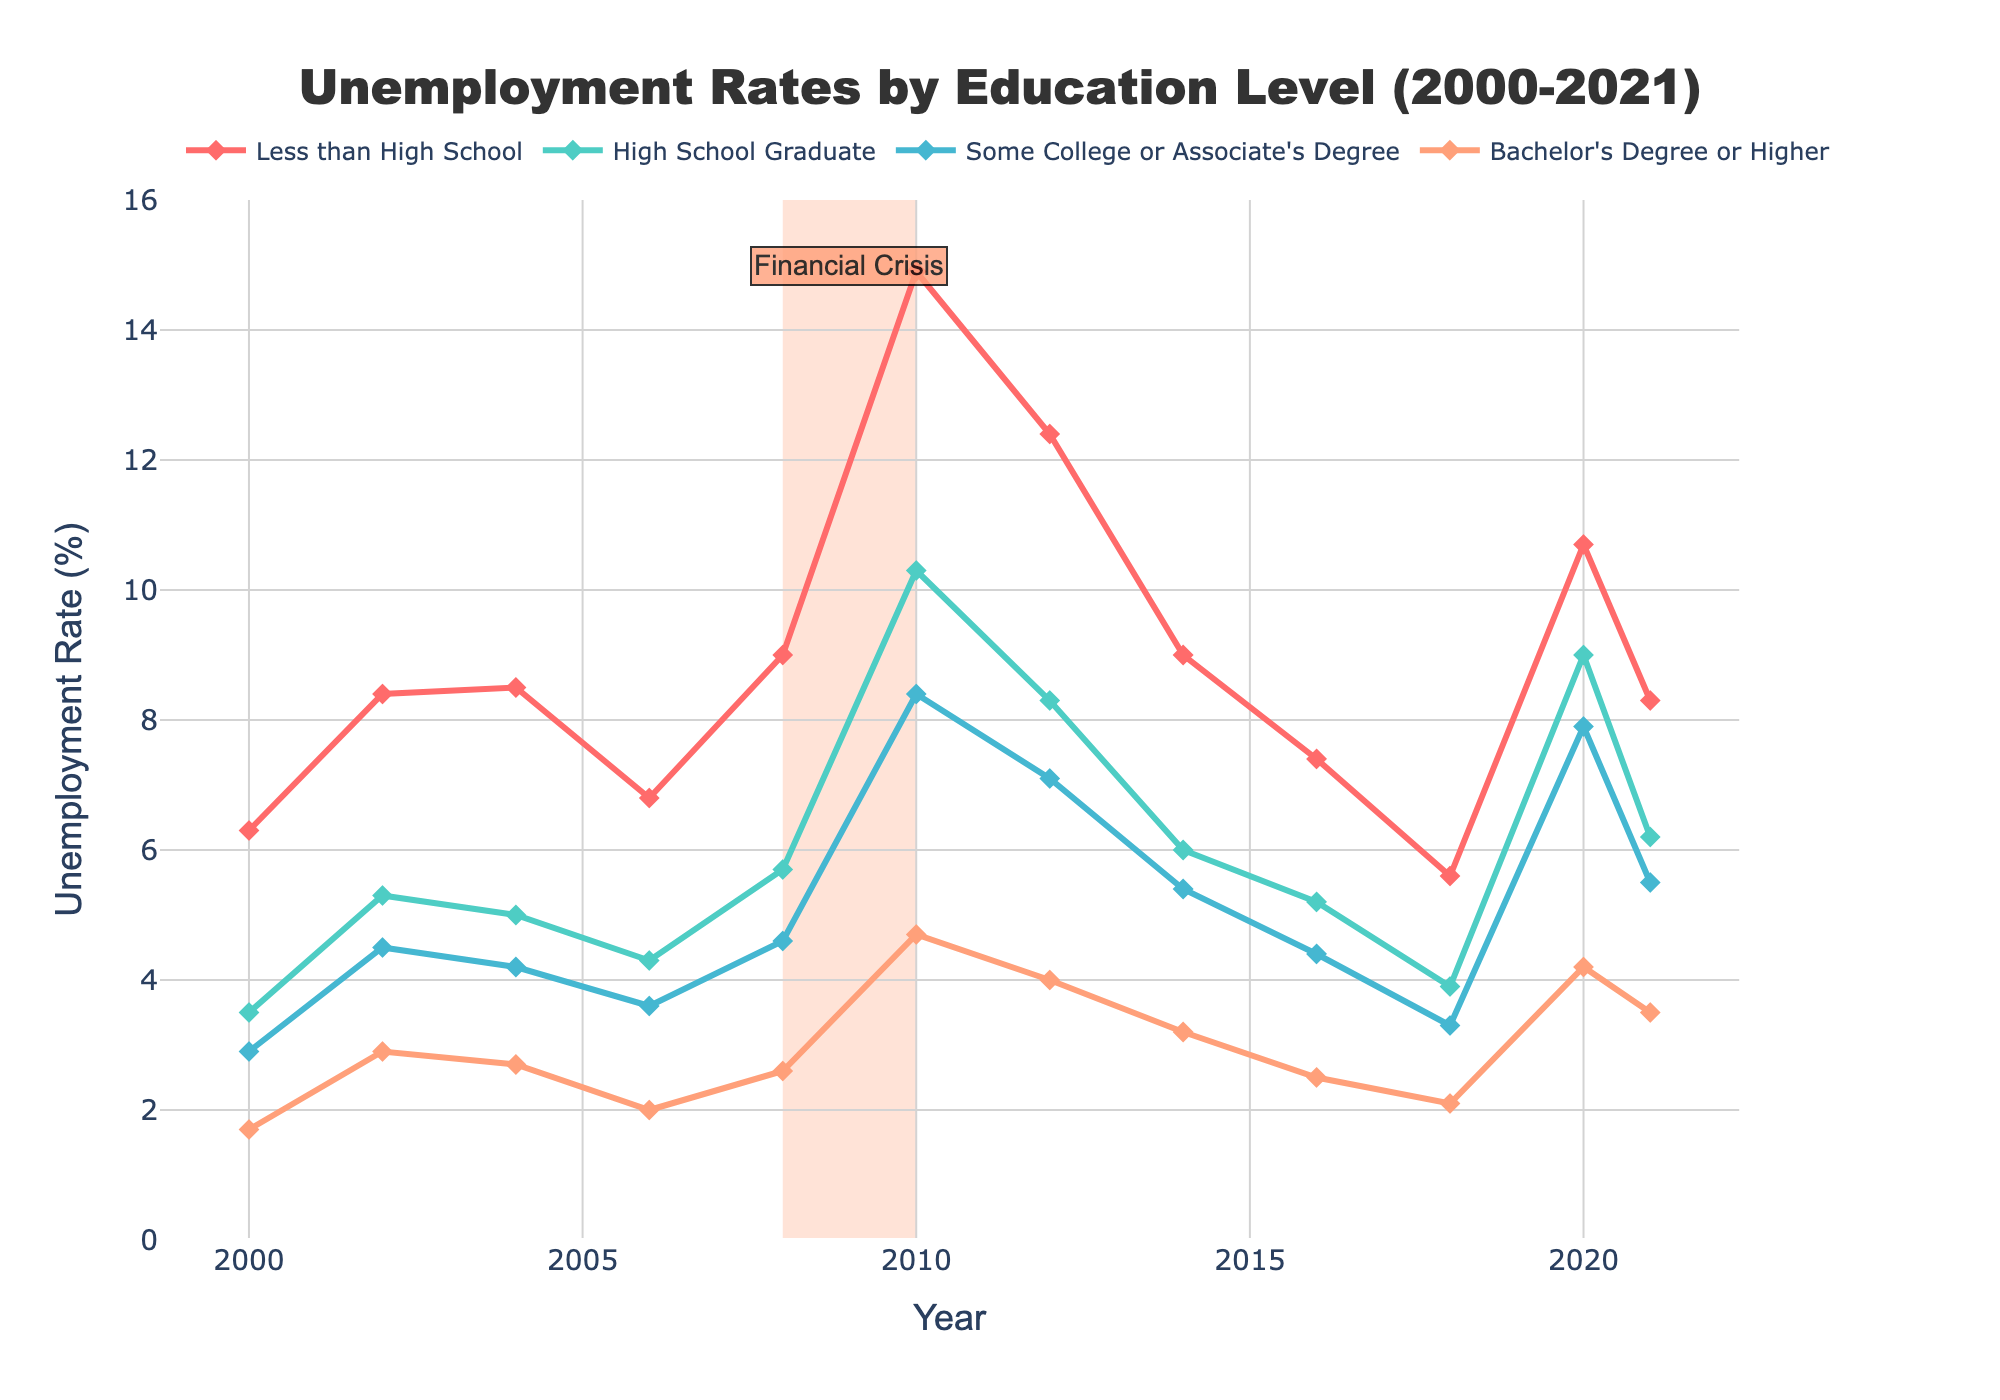What was the unemployment rate for 'High School Graduates' in 2010? Look at the point on the line corresponding to 'High School Graduate' for the year 2010 to find the unemployment rate.
Answer: 10.3% During which year did 'Less than High School' have the greatest unemployment rate? Identify the highest point on the line for 'Less than High School' and note the corresponding year.
Answer: 2010 How did the unemployment rate for 'Bachelor's Degree or Higher' change from 2008 to 2010? Compare the unemployment rates for 'Bachelor's Degree or Higher' at 2008 and 2010. Find the difference between these two values.
Answer: Increased by 1.6% Which education level had the lowest unemployment rate in 2018? Look at the unemployment rates for all education levels in 2018 and identify the lowest one.
Answer: Bachelor's Degree or Higher What was the average unemployment rate for 'Some College or Associate's Degree' over the entire period? Sum the unemployment rates for 'Some College or Associate's Degree' from 2000 to 2021 and divide by the number of years (12) to achieve the average.
Answer: 5.125% Between which consecutive years did 'High School Graduate' see the greatest increase in unemployment rate? Calculate the difference between each consecutive year's unemployment rates for 'High School Graduate' and find the largest increase.
Answer: 2008 to 2010 Which year had the largest combined unemployment rate for all education levels? Sum the unemployment rates for all education levels in each year and identify the year with the highest total.
Answer: 2010 Compare the overall trends of 'Less than High School' and 'Bachelor's Degree or Higher' from 2000 to 2021. Which one had more volatility in unemployment rates? Observe the fluctuation patterns of the lines representing 'Less than High School' and 'Bachelor's Degree or Higher', and identify which line shows more pronounced ups and downs.
Answer: Less than High School Identify a potential cause for the high unemployment rates observed between 2008 and 2010. Analyze the shaded area in the plot, which indicates a significant period, and the annotation about the 'Financial Crisis.'
Answer: Financial Crisis What was the unemployment rate difference between 'High School Graduate' and 'Bachelor's Degree or Higher' in 2020? Subtract the unemployment rate of 'Bachelor's Degree or Higher' from the unemployment rate of 'High School Graduate' in 2020.
Answer: 4.8% 